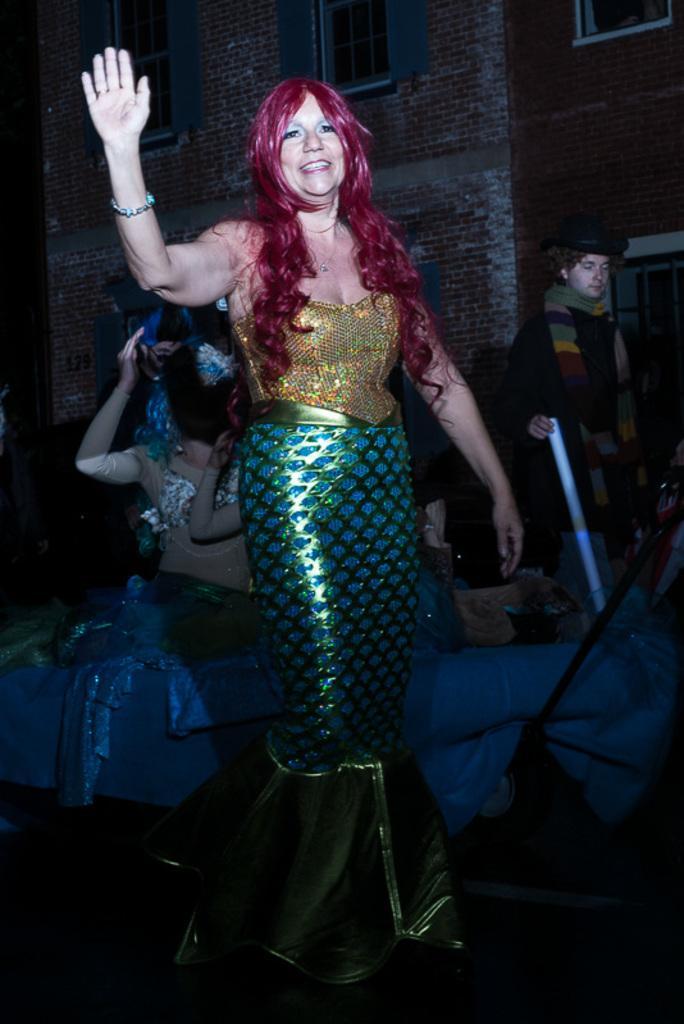Describe this image in one or two sentences. In this image, we can see people wearing costumes and in the background, there is a building and we can see a person holding an object and wearing a cap and a scarf and there are cloths. 